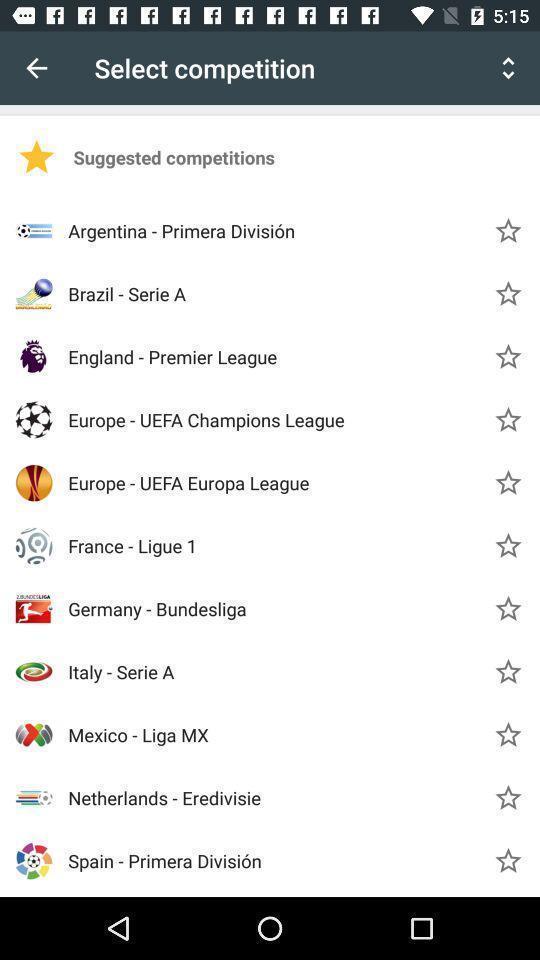Explain the elements present in this screenshot. Page showing list of competitions. 